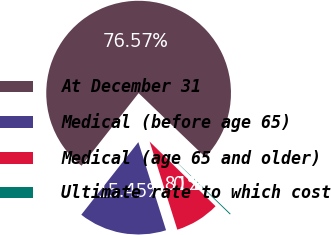Convert chart. <chart><loc_0><loc_0><loc_500><loc_500><pie_chart><fcel>At December 31<fcel>Medical (before age 65)<fcel>Medical (age 65 and older)<fcel>Ultimate rate to which cost<nl><fcel>76.57%<fcel>15.45%<fcel>7.81%<fcel>0.17%<nl></chart> 